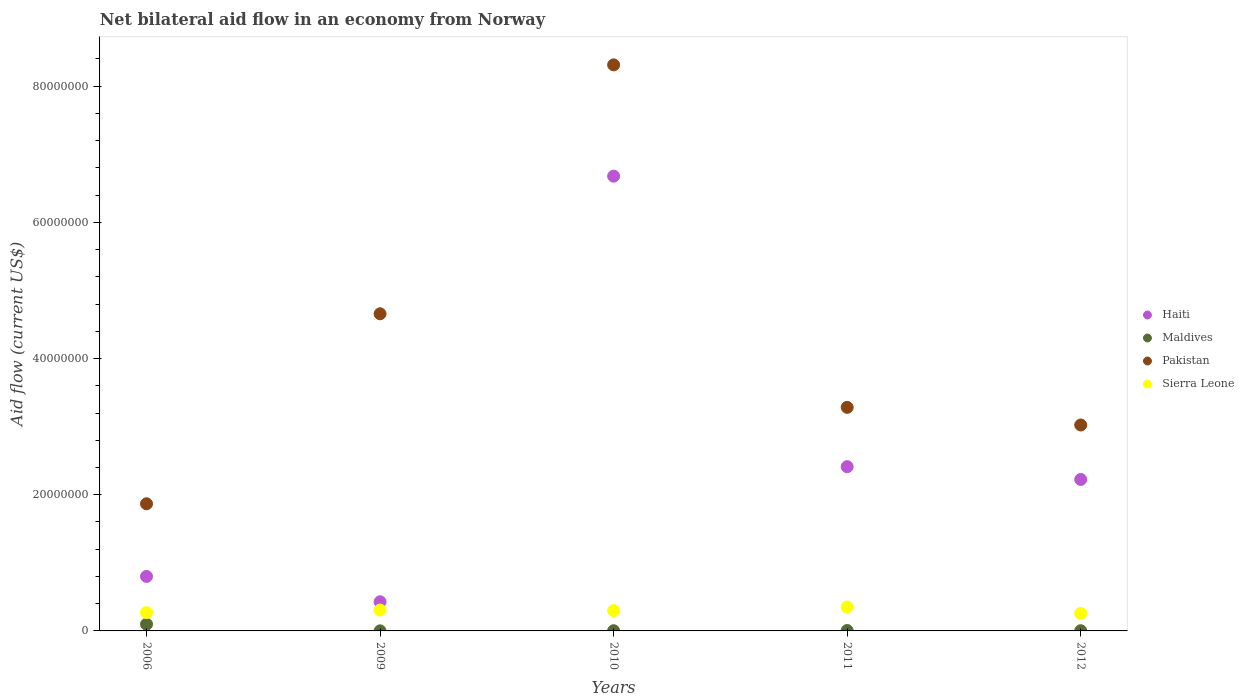How many different coloured dotlines are there?
Provide a succinct answer. 4. Across all years, what is the maximum net bilateral aid flow in Sierra Leone?
Keep it short and to the point. 3.52e+06. Across all years, what is the minimum net bilateral aid flow in Sierra Leone?
Your response must be concise. 2.57e+06. What is the total net bilateral aid flow in Haiti in the graph?
Make the answer very short. 1.25e+08. What is the difference between the net bilateral aid flow in Pakistan in 2006 and that in 2011?
Ensure brevity in your answer.  -1.42e+07. What is the difference between the net bilateral aid flow in Pakistan in 2006 and the net bilateral aid flow in Sierra Leone in 2012?
Offer a very short reply. 1.61e+07. What is the average net bilateral aid flow in Maldives per year?
Your response must be concise. 2.22e+05. In the year 2006, what is the difference between the net bilateral aid flow in Haiti and net bilateral aid flow in Maldives?
Provide a short and direct response. 7.02e+06. What is the ratio of the net bilateral aid flow in Haiti in 2009 to that in 2011?
Your response must be concise. 0.18. Is the difference between the net bilateral aid flow in Haiti in 2006 and 2011 greater than the difference between the net bilateral aid flow in Maldives in 2006 and 2011?
Make the answer very short. No. What is the difference between the highest and the second highest net bilateral aid flow in Pakistan?
Keep it short and to the point. 3.66e+07. What is the difference between the highest and the lowest net bilateral aid flow in Pakistan?
Your answer should be compact. 6.44e+07. Is the net bilateral aid flow in Sierra Leone strictly greater than the net bilateral aid flow in Maldives over the years?
Provide a succinct answer. Yes. Is the net bilateral aid flow in Pakistan strictly less than the net bilateral aid flow in Haiti over the years?
Your answer should be compact. No. How many dotlines are there?
Offer a terse response. 4. Are the values on the major ticks of Y-axis written in scientific E-notation?
Offer a terse response. No. Does the graph contain grids?
Provide a succinct answer. No. Where does the legend appear in the graph?
Your answer should be very brief. Center right. How many legend labels are there?
Ensure brevity in your answer.  4. What is the title of the graph?
Offer a very short reply. Net bilateral aid flow in an economy from Norway. What is the label or title of the X-axis?
Your response must be concise. Years. What is the Aid flow (current US$) in Haiti in 2006?
Your answer should be very brief. 8.00e+06. What is the Aid flow (current US$) in Maldives in 2006?
Your answer should be compact. 9.80e+05. What is the Aid flow (current US$) of Pakistan in 2006?
Your response must be concise. 1.87e+07. What is the Aid flow (current US$) of Sierra Leone in 2006?
Your response must be concise. 2.69e+06. What is the Aid flow (current US$) in Haiti in 2009?
Your response must be concise. 4.28e+06. What is the Aid flow (current US$) in Pakistan in 2009?
Provide a short and direct response. 4.66e+07. What is the Aid flow (current US$) of Sierra Leone in 2009?
Offer a very short reply. 3.07e+06. What is the Aid flow (current US$) in Haiti in 2010?
Keep it short and to the point. 6.68e+07. What is the Aid flow (current US$) in Pakistan in 2010?
Your answer should be compact. 8.31e+07. What is the Aid flow (current US$) of Sierra Leone in 2010?
Offer a very short reply. 2.98e+06. What is the Aid flow (current US$) of Haiti in 2011?
Your answer should be very brief. 2.41e+07. What is the Aid flow (current US$) of Maldives in 2011?
Keep it short and to the point. 6.00e+04. What is the Aid flow (current US$) in Pakistan in 2011?
Make the answer very short. 3.28e+07. What is the Aid flow (current US$) of Sierra Leone in 2011?
Provide a succinct answer. 3.52e+06. What is the Aid flow (current US$) of Haiti in 2012?
Your response must be concise. 2.22e+07. What is the Aid flow (current US$) of Pakistan in 2012?
Ensure brevity in your answer.  3.02e+07. What is the Aid flow (current US$) in Sierra Leone in 2012?
Make the answer very short. 2.57e+06. Across all years, what is the maximum Aid flow (current US$) in Haiti?
Provide a short and direct response. 6.68e+07. Across all years, what is the maximum Aid flow (current US$) in Maldives?
Your answer should be very brief. 9.80e+05. Across all years, what is the maximum Aid flow (current US$) of Pakistan?
Provide a succinct answer. 8.31e+07. Across all years, what is the maximum Aid flow (current US$) in Sierra Leone?
Offer a terse response. 3.52e+06. Across all years, what is the minimum Aid flow (current US$) in Haiti?
Your answer should be very brief. 4.28e+06. Across all years, what is the minimum Aid flow (current US$) of Pakistan?
Provide a short and direct response. 1.87e+07. Across all years, what is the minimum Aid flow (current US$) of Sierra Leone?
Provide a succinct answer. 2.57e+06. What is the total Aid flow (current US$) of Haiti in the graph?
Your answer should be compact. 1.25e+08. What is the total Aid flow (current US$) in Maldives in the graph?
Offer a terse response. 1.11e+06. What is the total Aid flow (current US$) of Pakistan in the graph?
Your answer should be compact. 2.11e+08. What is the total Aid flow (current US$) in Sierra Leone in the graph?
Your response must be concise. 1.48e+07. What is the difference between the Aid flow (current US$) in Haiti in 2006 and that in 2009?
Make the answer very short. 3.72e+06. What is the difference between the Aid flow (current US$) in Maldives in 2006 and that in 2009?
Keep it short and to the point. 9.70e+05. What is the difference between the Aid flow (current US$) of Pakistan in 2006 and that in 2009?
Keep it short and to the point. -2.79e+07. What is the difference between the Aid flow (current US$) in Sierra Leone in 2006 and that in 2009?
Your answer should be very brief. -3.80e+05. What is the difference between the Aid flow (current US$) of Haiti in 2006 and that in 2010?
Your answer should be very brief. -5.88e+07. What is the difference between the Aid flow (current US$) of Maldives in 2006 and that in 2010?
Offer a very short reply. 9.50e+05. What is the difference between the Aid flow (current US$) of Pakistan in 2006 and that in 2010?
Make the answer very short. -6.44e+07. What is the difference between the Aid flow (current US$) of Haiti in 2006 and that in 2011?
Provide a succinct answer. -1.61e+07. What is the difference between the Aid flow (current US$) of Maldives in 2006 and that in 2011?
Give a very brief answer. 9.20e+05. What is the difference between the Aid flow (current US$) of Pakistan in 2006 and that in 2011?
Your response must be concise. -1.42e+07. What is the difference between the Aid flow (current US$) of Sierra Leone in 2006 and that in 2011?
Offer a very short reply. -8.30e+05. What is the difference between the Aid flow (current US$) in Haiti in 2006 and that in 2012?
Provide a short and direct response. -1.42e+07. What is the difference between the Aid flow (current US$) of Maldives in 2006 and that in 2012?
Make the answer very short. 9.50e+05. What is the difference between the Aid flow (current US$) in Pakistan in 2006 and that in 2012?
Your response must be concise. -1.16e+07. What is the difference between the Aid flow (current US$) of Haiti in 2009 and that in 2010?
Make the answer very short. -6.25e+07. What is the difference between the Aid flow (current US$) in Pakistan in 2009 and that in 2010?
Ensure brevity in your answer.  -3.66e+07. What is the difference between the Aid flow (current US$) in Sierra Leone in 2009 and that in 2010?
Offer a terse response. 9.00e+04. What is the difference between the Aid flow (current US$) of Haiti in 2009 and that in 2011?
Make the answer very short. -1.98e+07. What is the difference between the Aid flow (current US$) of Maldives in 2009 and that in 2011?
Offer a very short reply. -5.00e+04. What is the difference between the Aid flow (current US$) of Pakistan in 2009 and that in 2011?
Provide a succinct answer. 1.37e+07. What is the difference between the Aid flow (current US$) of Sierra Leone in 2009 and that in 2011?
Provide a short and direct response. -4.50e+05. What is the difference between the Aid flow (current US$) of Haiti in 2009 and that in 2012?
Your answer should be very brief. -1.80e+07. What is the difference between the Aid flow (current US$) in Pakistan in 2009 and that in 2012?
Offer a terse response. 1.63e+07. What is the difference between the Aid flow (current US$) in Sierra Leone in 2009 and that in 2012?
Provide a succinct answer. 5.00e+05. What is the difference between the Aid flow (current US$) of Haiti in 2010 and that in 2011?
Your response must be concise. 4.27e+07. What is the difference between the Aid flow (current US$) of Maldives in 2010 and that in 2011?
Your response must be concise. -3.00e+04. What is the difference between the Aid flow (current US$) in Pakistan in 2010 and that in 2011?
Provide a short and direct response. 5.03e+07. What is the difference between the Aid flow (current US$) in Sierra Leone in 2010 and that in 2011?
Give a very brief answer. -5.40e+05. What is the difference between the Aid flow (current US$) in Haiti in 2010 and that in 2012?
Offer a very short reply. 4.45e+07. What is the difference between the Aid flow (current US$) in Maldives in 2010 and that in 2012?
Provide a succinct answer. 0. What is the difference between the Aid flow (current US$) of Pakistan in 2010 and that in 2012?
Your answer should be very brief. 5.29e+07. What is the difference between the Aid flow (current US$) of Sierra Leone in 2010 and that in 2012?
Your answer should be compact. 4.10e+05. What is the difference between the Aid flow (current US$) of Haiti in 2011 and that in 2012?
Ensure brevity in your answer.  1.88e+06. What is the difference between the Aid flow (current US$) in Maldives in 2011 and that in 2012?
Ensure brevity in your answer.  3.00e+04. What is the difference between the Aid flow (current US$) of Pakistan in 2011 and that in 2012?
Keep it short and to the point. 2.59e+06. What is the difference between the Aid flow (current US$) of Sierra Leone in 2011 and that in 2012?
Make the answer very short. 9.50e+05. What is the difference between the Aid flow (current US$) in Haiti in 2006 and the Aid flow (current US$) in Maldives in 2009?
Offer a terse response. 7.99e+06. What is the difference between the Aid flow (current US$) in Haiti in 2006 and the Aid flow (current US$) in Pakistan in 2009?
Your response must be concise. -3.86e+07. What is the difference between the Aid flow (current US$) of Haiti in 2006 and the Aid flow (current US$) of Sierra Leone in 2009?
Ensure brevity in your answer.  4.93e+06. What is the difference between the Aid flow (current US$) of Maldives in 2006 and the Aid flow (current US$) of Pakistan in 2009?
Offer a very short reply. -4.56e+07. What is the difference between the Aid flow (current US$) in Maldives in 2006 and the Aid flow (current US$) in Sierra Leone in 2009?
Make the answer very short. -2.09e+06. What is the difference between the Aid flow (current US$) in Pakistan in 2006 and the Aid flow (current US$) in Sierra Leone in 2009?
Offer a very short reply. 1.56e+07. What is the difference between the Aid flow (current US$) in Haiti in 2006 and the Aid flow (current US$) in Maldives in 2010?
Give a very brief answer. 7.97e+06. What is the difference between the Aid flow (current US$) of Haiti in 2006 and the Aid flow (current US$) of Pakistan in 2010?
Give a very brief answer. -7.51e+07. What is the difference between the Aid flow (current US$) of Haiti in 2006 and the Aid flow (current US$) of Sierra Leone in 2010?
Your answer should be very brief. 5.02e+06. What is the difference between the Aid flow (current US$) of Maldives in 2006 and the Aid flow (current US$) of Pakistan in 2010?
Your answer should be very brief. -8.21e+07. What is the difference between the Aid flow (current US$) in Pakistan in 2006 and the Aid flow (current US$) in Sierra Leone in 2010?
Give a very brief answer. 1.57e+07. What is the difference between the Aid flow (current US$) in Haiti in 2006 and the Aid flow (current US$) in Maldives in 2011?
Provide a succinct answer. 7.94e+06. What is the difference between the Aid flow (current US$) of Haiti in 2006 and the Aid flow (current US$) of Pakistan in 2011?
Your response must be concise. -2.48e+07. What is the difference between the Aid flow (current US$) of Haiti in 2006 and the Aid flow (current US$) of Sierra Leone in 2011?
Offer a terse response. 4.48e+06. What is the difference between the Aid flow (current US$) of Maldives in 2006 and the Aid flow (current US$) of Pakistan in 2011?
Your answer should be very brief. -3.18e+07. What is the difference between the Aid flow (current US$) in Maldives in 2006 and the Aid flow (current US$) in Sierra Leone in 2011?
Ensure brevity in your answer.  -2.54e+06. What is the difference between the Aid flow (current US$) in Pakistan in 2006 and the Aid flow (current US$) in Sierra Leone in 2011?
Your response must be concise. 1.52e+07. What is the difference between the Aid flow (current US$) in Haiti in 2006 and the Aid flow (current US$) in Maldives in 2012?
Make the answer very short. 7.97e+06. What is the difference between the Aid flow (current US$) in Haiti in 2006 and the Aid flow (current US$) in Pakistan in 2012?
Provide a succinct answer. -2.22e+07. What is the difference between the Aid flow (current US$) of Haiti in 2006 and the Aid flow (current US$) of Sierra Leone in 2012?
Provide a short and direct response. 5.43e+06. What is the difference between the Aid flow (current US$) in Maldives in 2006 and the Aid flow (current US$) in Pakistan in 2012?
Offer a very short reply. -2.93e+07. What is the difference between the Aid flow (current US$) of Maldives in 2006 and the Aid flow (current US$) of Sierra Leone in 2012?
Keep it short and to the point. -1.59e+06. What is the difference between the Aid flow (current US$) in Pakistan in 2006 and the Aid flow (current US$) in Sierra Leone in 2012?
Your answer should be compact. 1.61e+07. What is the difference between the Aid flow (current US$) in Haiti in 2009 and the Aid flow (current US$) in Maldives in 2010?
Your answer should be compact. 4.25e+06. What is the difference between the Aid flow (current US$) in Haiti in 2009 and the Aid flow (current US$) in Pakistan in 2010?
Make the answer very short. -7.88e+07. What is the difference between the Aid flow (current US$) in Haiti in 2009 and the Aid flow (current US$) in Sierra Leone in 2010?
Provide a succinct answer. 1.30e+06. What is the difference between the Aid flow (current US$) in Maldives in 2009 and the Aid flow (current US$) in Pakistan in 2010?
Provide a short and direct response. -8.31e+07. What is the difference between the Aid flow (current US$) of Maldives in 2009 and the Aid flow (current US$) of Sierra Leone in 2010?
Give a very brief answer. -2.97e+06. What is the difference between the Aid flow (current US$) of Pakistan in 2009 and the Aid flow (current US$) of Sierra Leone in 2010?
Provide a succinct answer. 4.36e+07. What is the difference between the Aid flow (current US$) in Haiti in 2009 and the Aid flow (current US$) in Maldives in 2011?
Provide a short and direct response. 4.22e+06. What is the difference between the Aid flow (current US$) in Haiti in 2009 and the Aid flow (current US$) in Pakistan in 2011?
Make the answer very short. -2.86e+07. What is the difference between the Aid flow (current US$) in Haiti in 2009 and the Aid flow (current US$) in Sierra Leone in 2011?
Give a very brief answer. 7.60e+05. What is the difference between the Aid flow (current US$) of Maldives in 2009 and the Aid flow (current US$) of Pakistan in 2011?
Your answer should be compact. -3.28e+07. What is the difference between the Aid flow (current US$) in Maldives in 2009 and the Aid flow (current US$) in Sierra Leone in 2011?
Give a very brief answer. -3.51e+06. What is the difference between the Aid flow (current US$) in Pakistan in 2009 and the Aid flow (current US$) in Sierra Leone in 2011?
Provide a succinct answer. 4.30e+07. What is the difference between the Aid flow (current US$) in Haiti in 2009 and the Aid flow (current US$) in Maldives in 2012?
Your answer should be compact. 4.25e+06. What is the difference between the Aid flow (current US$) in Haiti in 2009 and the Aid flow (current US$) in Pakistan in 2012?
Give a very brief answer. -2.60e+07. What is the difference between the Aid flow (current US$) of Haiti in 2009 and the Aid flow (current US$) of Sierra Leone in 2012?
Give a very brief answer. 1.71e+06. What is the difference between the Aid flow (current US$) in Maldives in 2009 and the Aid flow (current US$) in Pakistan in 2012?
Make the answer very short. -3.02e+07. What is the difference between the Aid flow (current US$) in Maldives in 2009 and the Aid flow (current US$) in Sierra Leone in 2012?
Provide a succinct answer. -2.56e+06. What is the difference between the Aid flow (current US$) in Pakistan in 2009 and the Aid flow (current US$) in Sierra Leone in 2012?
Make the answer very short. 4.40e+07. What is the difference between the Aid flow (current US$) of Haiti in 2010 and the Aid flow (current US$) of Maldives in 2011?
Make the answer very short. 6.67e+07. What is the difference between the Aid flow (current US$) in Haiti in 2010 and the Aid flow (current US$) in Pakistan in 2011?
Keep it short and to the point. 3.40e+07. What is the difference between the Aid flow (current US$) of Haiti in 2010 and the Aid flow (current US$) of Sierra Leone in 2011?
Provide a succinct answer. 6.33e+07. What is the difference between the Aid flow (current US$) in Maldives in 2010 and the Aid flow (current US$) in Pakistan in 2011?
Give a very brief answer. -3.28e+07. What is the difference between the Aid flow (current US$) in Maldives in 2010 and the Aid flow (current US$) in Sierra Leone in 2011?
Make the answer very short. -3.49e+06. What is the difference between the Aid flow (current US$) in Pakistan in 2010 and the Aid flow (current US$) in Sierra Leone in 2011?
Provide a short and direct response. 7.96e+07. What is the difference between the Aid flow (current US$) of Haiti in 2010 and the Aid flow (current US$) of Maldives in 2012?
Offer a very short reply. 6.68e+07. What is the difference between the Aid flow (current US$) in Haiti in 2010 and the Aid flow (current US$) in Pakistan in 2012?
Provide a succinct answer. 3.65e+07. What is the difference between the Aid flow (current US$) in Haiti in 2010 and the Aid flow (current US$) in Sierra Leone in 2012?
Provide a succinct answer. 6.42e+07. What is the difference between the Aid flow (current US$) in Maldives in 2010 and the Aid flow (current US$) in Pakistan in 2012?
Keep it short and to the point. -3.02e+07. What is the difference between the Aid flow (current US$) in Maldives in 2010 and the Aid flow (current US$) in Sierra Leone in 2012?
Make the answer very short. -2.54e+06. What is the difference between the Aid flow (current US$) of Pakistan in 2010 and the Aid flow (current US$) of Sierra Leone in 2012?
Provide a succinct answer. 8.06e+07. What is the difference between the Aid flow (current US$) in Haiti in 2011 and the Aid flow (current US$) in Maldives in 2012?
Keep it short and to the point. 2.41e+07. What is the difference between the Aid flow (current US$) in Haiti in 2011 and the Aid flow (current US$) in Pakistan in 2012?
Offer a terse response. -6.12e+06. What is the difference between the Aid flow (current US$) of Haiti in 2011 and the Aid flow (current US$) of Sierra Leone in 2012?
Provide a succinct answer. 2.16e+07. What is the difference between the Aid flow (current US$) in Maldives in 2011 and the Aid flow (current US$) in Pakistan in 2012?
Keep it short and to the point. -3.02e+07. What is the difference between the Aid flow (current US$) in Maldives in 2011 and the Aid flow (current US$) in Sierra Leone in 2012?
Offer a terse response. -2.51e+06. What is the difference between the Aid flow (current US$) in Pakistan in 2011 and the Aid flow (current US$) in Sierra Leone in 2012?
Provide a succinct answer. 3.03e+07. What is the average Aid flow (current US$) in Haiti per year?
Your answer should be compact. 2.51e+07. What is the average Aid flow (current US$) of Maldives per year?
Offer a very short reply. 2.22e+05. What is the average Aid flow (current US$) in Pakistan per year?
Give a very brief answer. 4.23e+07. What is the average Aid flow (current US$) in Sierra Leone per year?
Your response must be concise. 2.97e+06. In the year 2006, what is the difference between the Aid flow (current US$) in Haiti and Aid flow (current US$) in Maldives?
Provide a short and direct response. 7.02e+06. In the year 2006, what is the difference between the Aid flow (current US$) of Haiti and Aid flow (current US$) of Pakistan?
Provide a succinct answer. -1.07e+07. In the year 2006, what is the difference between the Aid flow (current US$) in Haiti and Aid flow (current US$) in Sierra Leone?
Offer a terse response. 5.31e+06. In the year 2006, what is the difference between the Aid flow (current US$) in Maldives and Aid flow (current US$) in Pakistan?
Offer a very short reply. -1.77e+07. In the year 2006, what is the difference between the Aid flow (current US$) in Maldives and Aid flow (current US$) in Sierra Leone?
Ensure brevity in your answer.  -1.71e+06. In the year 2006, what is the difference between the Aid flow (current US$) in Pakistan and Aid flow (current US$) in Sierra Leone?
Your response must be concise. 1.60e+07. In the year 2009, what is the difference between the Aid flow (current US$) of Haiti and Aid flow (current US$) of Maldives?
Give a very brief answer. 4.27e+06. In the year 2009, what is the difference between the Aid flow (current US$) in Haiti and Aid flow (current US$) in Pakistan?
Ensure brevity in your answer.  -4.23e+07. In the year 2009, what is the difference between the Aid flow (current US$) in Haiti and Aid flow (current US$) in Sierra Leone?
Offer a terse response. 1.21e+06. In the year 2009, what is the difference between the Aid flow (current US$) in Maldives and Aid flow (current US$) in Pakistan?
Make the answer very short. -4.66e+07. In the year 2009, what is the difference between the Aid flow (current US$) of Maldives and Aid flow (current US$) of Sierra Leone?
Your response must be concise. -3.06e+06. In the year 2009, what is the difference between the Aid flow (current US$) in Pakistan and Aid flow (current US$) in Sierra Leone?
Keep it short and to the point. 4.35e+07. In the year 2010, what is the difference between the Aid flow (current US$) of Haiti and Aid flow (current US$) of Maldives?
Offer a terse response. 6.68e+07. In the year 2010, what is the difference between the Aid flow (current US$) of Haiti and Aid flow (current US$) of Pakistan?
Your response must be concise. -1.63e+07. In the year 2010, what is the difference between the Aid flow (current US$) in Haiti and Aid flow (current US$) in Sierra Leone?
Your answer should be very brief. 6.38e+07. In the year 2010, what is the difference between the Aid flow (current US$) in Maldives and Aid flow (current US$) in Pakistan?
Your answer should be compact. -8.31e+07. In the year 2010, what is the difference between the Aid flow (current US$) of Maldives and Aid flow (current US$) of Sierra Leone?
Your answer should be compact. -2.95e+06. In the year 2010, what is the difference between the Aid flow (current US$) of Pakistan and Aid flow (current US$) of Sierra Leone?
Your answer should be compact. 8.01e+07. In the year 2011, what is the difference between the Aid flow (current US$) of Haiti and Aid flow (current US$) of Maldives?
Your answer should be very brief. 2.41e+07. In the year 2011, what is the difference between the Aid flow (current US$) in Haiti and Aid flow (current US$) in Pakistan?
Your answer should be compact. -8.71e+06. In the year 2011, what is the difference between the Aid flow (current US$) of Haiti and Aid flow (current US$) of Sierra Leone?
Ensure brevity in your answer.  2.06e+07. In the year 2011, what is the difference between the Aid flow (current US$) in Maldives and Aid flow (current US$) in Pakistan?
Offer a very short reply. -3.28e+07. In the year 2011, what is the difference between the Aid flow (current US$) in Maldives and Aid flow (current US$) in Sierra Leone?
Your answer should be very brief. -3.46e+06. In the year 2011, what is the difference between the Aid flow (current US$) in Pakistan and Aid flow (current US$) in Sierra Leone?
Make the answer very short. 2.93e+07. In the year 2012, what is the difference between the Aid flow (current US$) in Haiti and Aid flow (current US$) in Maldives?
Ensure brevity in your answer.  2.22e+07. In the year 2012, what is the difference between the Aid flow (current US$) in Haiti and Aid flow (current US$) in Pakistan?
Ensure brevity in your answer.  -8.00e+06. In the year 2012, what is the difference between the Aid flow (current US$) of Haiti and Aid flow (current US$) of Sierra Leone?
Ensure brevity in your answer.  1.97e+07. In the year 2012, what is the difference between the Aid flow (current US$) in Maldives and Aid flow (current US$) in Pakistan?
Provide a short and direct response. -3.02e+07. In the year 2012, what is the difference between the Aid flow (current US$) in Maldives and Aid flow (current US$) in Sierra Leone?
Your answer should be compact. -2.54e+06. In the year 2012, what is the difference between the Aid flow (current US$) in Pakistan and Aid flow (current US$) in Sierra Leone?
Your response must be concise. 2.77e+07. What is the ratio of the Aid flow (current US$) of Haiti in 2006 to that in 2009?
Provide a short and direct response. 1.87. What is the ratio of the Aid flow (current US$) of Maldives in 2006 to that in 2009?
Keep it short and to the point. 98. What is the ratio of the Aid flow (current US$) of Pakistan in 2006 to that in 2009?
Ensure brevity in your answer.  0.4. What is the ratio of the Aid flow (current US$) in Sierra Leone in 2006 to that in 2009?
Offer a very short reply. 0.88. What is the ratio of the Aid flow (current US$) in Haiti in 2006 to that in 2010?
Give a very brief answer. 0.12. What is the ratio of the Aid flow (current US$) of Maldives in 2006 to that in 2010?
Ensure brevity in your answer.  32.67. What is the ratio of the Aid flow (current US$) in Pakistan in 2006 to that in 2010?
Provide a short and direct response. 0.22. What is the ratio of the Aid flow (current US$) of Sierra Leone in 2006 to that in 2010?
Offer a terse response. 0.9. What is the ratio of the Aid flow (current US$) in Haiti in 2006 to that in 2011?
Offer a terse response. 0.33. What is the ratio of the Aid flow (current US$) in Maldives in 2006 to that in 2011?
Make the answer very short. 16.33. What is the ratio of the Aid flow (current US$) of Pakistan in 2006 to that in 2011?
Provide a short and direct response. 0.57. What is the ratio of the Aid flow (current US$) of Sierra Leone in 2006 to that in 2011?
Your answer should be compact. 0.76. What is the ratio of the Aid flow (current US$) of Haiti in 2006 to that in 2012?
Make the answer very short. 0.36. What is the ratio of the Aid flow (current US$) of Maldives in 2006 to that in 2012?
Your answer should be very brief. 32.67. What is the ratio of the Aid flow (current US$) in Pakistan in 2006 to that in 2012?
Make the answer very short. 0.62. What is the ratio of the Aid flow (current US$) of Sierra Leone in 2006 to that in 2012?
Your answer should be compact. 1.05. What is the ratio of the Aid flow (current US$) in Haiti in 2009 to that in 2010?
Your answer should be very brief. 0.06. What is the ratio of the Aid flow (current US$) in Maldives in 2009 to that in 2010?
Keep it short and to the point. 0.33. What is the ratio of the Aid flow (current US$) of Pakistan in 2009 to that in 2010?
Your answer should be compact. 0.56. What is the ratio of the Aid flow (current US$) in Sierra Leone in 2009 to that in 2010?
Keep it short and to the point. 1.03. What is the ratio of the Aid flow (current US$) in Haiti in 2009 to that in 2011?
Ensure brevity in your answer.  0.18. What is the ratio of the Aid flow (current US$) in Maldives in 2009 to that in 2011?
Keep it short and to the point. 0.17. What is the ratio of the Aid flow (current US$) in Pakistan in 2009 to that in 2011?
Your response must be concise. 1.42. What is the ratio of the Aid flow (current US$) of Sierra Leone in 2009 to that in 2011?
Provide a short and direct response. 0.87. What is the ratio of the Aid flow (current US$) in Haiti in 2009 to that in 2012?
Give a very brief answer. 0.19. What is the ratio of the Aid flow (current US$) of Maldives in 2009 to that in 2012?
Offer a terse response. 0.33. What is the ratio of the Aid flow (current US$) in Pakistan in 2009 to that in 2012?
Keep it short and to the point. 1.54. What is the ratio of the Aid flow (current US$) of Sierra Leone in 2009 to that in 2012?
Keep it short and to the point. 1.19. What is the ratio of the Aid flow (current US$) of Haiti in 2010 to that in 2011?
Offer a terse response. 2.77. What is the ratio of the Aid flow (current US$) in Maldives in 2010 to that in 2011?
Keep it short and to the point. 0.5. What is the ratio of the Aid flow (current US$) in Pakistan in 2010 to that in 2011?
Your answer should be compact. 2.53. What is the ratio of the Aid flow (current US$) of Sierra Leone in 2010 to that in 2011?
Offer a very short reply. 0.85. What is the ratio of the Aid flow (current US$) of Haiti in 2010 to that in 2012?
Make the answer very short. 3. What is the ratio of the Aid flow (current US$) of Pakistan in 2010 to that in 2012?
Offer a terse response. 2.75. What is the ratio of the Aid flow (current US$) in Sierra Leone in 2010 to that in 2012?
Ensure brevity in your answer.  1.16. What is the ratio of the Aid flow (current US$) in Haiti in 2011 to that in 2012?
Keep it short and to the point. 1.08. What is the ratio of the Aid flow (current US$) of Maldives in 2011 to that in 2012?
Keep it short and to the point. 2. What is the ratio of the Aid flow (current US$) of Pakistan in 2011 to that in 2012?
Ensure brevity in your answer.  1.09. What is the ratio of the Aid flow (current US$) in Sierra Leone in 2011 to that in 2012?
Provide a succinct answer. 1.37. What is the difference between the highest and the second highest Aid flow (current US$) in Haiti?
Your response must be concise. 4.27e+07. What is the difference between the highest and the second highest Aid flow (current US$) in Maldives?
Give a very brief answer. 9.20e+05. What is the difference between the highest and the second highest Aid flow (current US$) in Pakistan?
Your answer should be compact. 3.66e+07. What is the difference between the highest and the lowest Aid flow (current US$) in Haiti?
Make the answer very short. 6.25e+07. What is the difference between the highest and the lowest Aid flow (current US$) of Maldives?
Keep it short and to the point. 9.70e+05. What is the difference between the highest and the lowest Aid flow (current US$) in Pakistan?
Ensure brevity in your answer.  6.44e+07. What is the difference between the highest and the lowest Aid flow (current US$) in Sierra Leone?
Your response must be concise. 9.50e+05. 